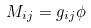<formula> <loc_0><loc_0><loc_500><loc_500>M _ { i j } = g _ { i j } \phi \</formula> 